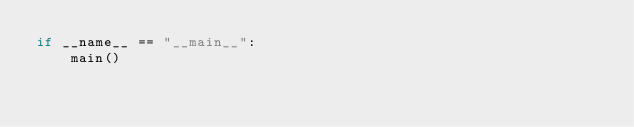<code> <loc_0><loc_0><loc_500><loc_500><_Python_>if __name__ == "__main__":
    main()
</code> 